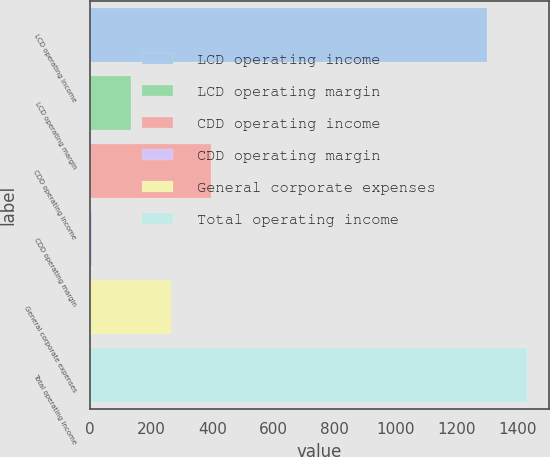Convert chart. <chart><loc_0><loc_0><loc_500><loc_500><bar_chart><fcel>LCD operating income<fcel>LCD operating margin<fcel>CDD operating income<fcel>CDD operating margin<fcel>General corporate expenses<fcel>Total operating income<nl><fcel>1300.9<fcel>134.3<fcel>394.5<fcel>4.2<fcel>264.4<fcel>1431<nl></chart> 